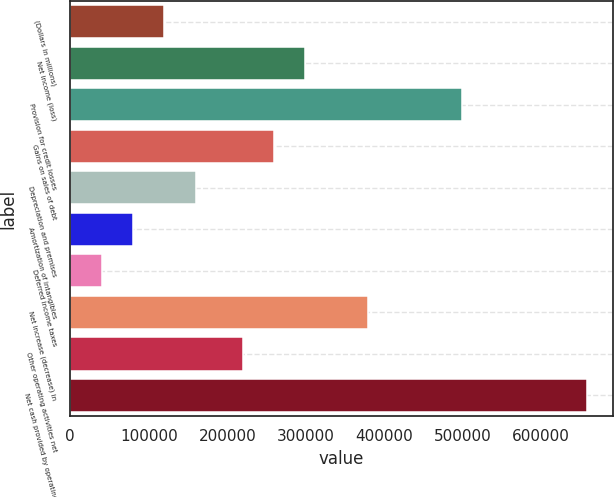<chart> <loc_0><loc_0><loc_500><loc_500><bar_chart><fcel>(Dollars in millions)<fcel>Net income (loss)<fcel>Provision for credit losses<fcel>Gains on sales of debt<fcel>Depreciation and premises<fcel>Amortization of intangibles<fcel>Deferred income taxes<fcel>Net increase (decrease) in<fcel>Other operating activities net<fcel>Net cash provided by operating<nl><fcel>119753<fcel>299336<fcel>498874<fcel>259429<fcel>159661<fcel>79845.8<fcel>39938.4<fcel>379151<fcel>219522<fcel>658503<nl></chart> 